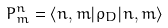Convert formula to latex. <formula><loc_0><loc_0><loc_500><loc_500>P ^ { n } _ { m } = \langle n , m | \rho _ { D } | n , m \rangle</formula> 